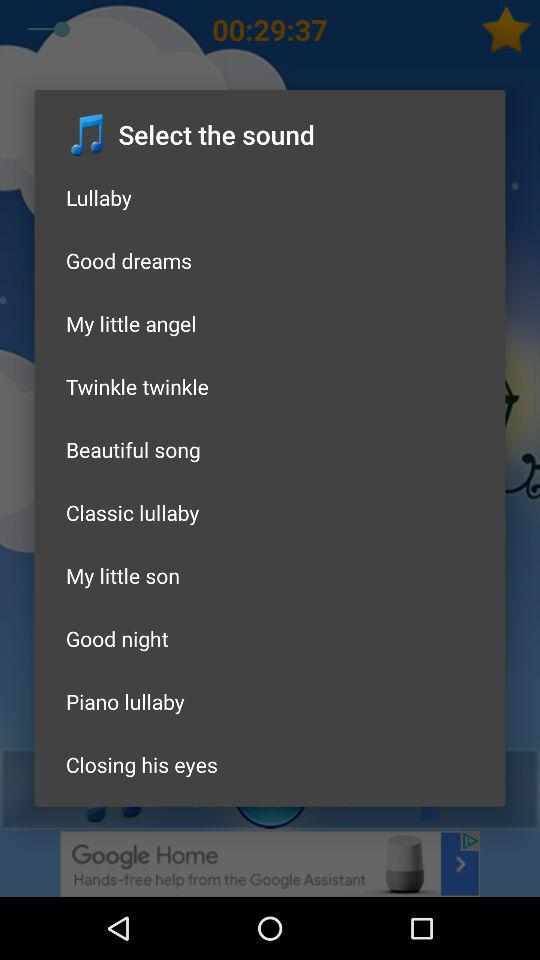What are the available sounds in the list? The available sounds in the list are "Lullaby", "Good dreams", "My little angel", "Twinkle twinkle", "Beautiful song", "Classic lullaby", "My little son", "Good night", "Piano lullaby" and "Closing his eyes". 